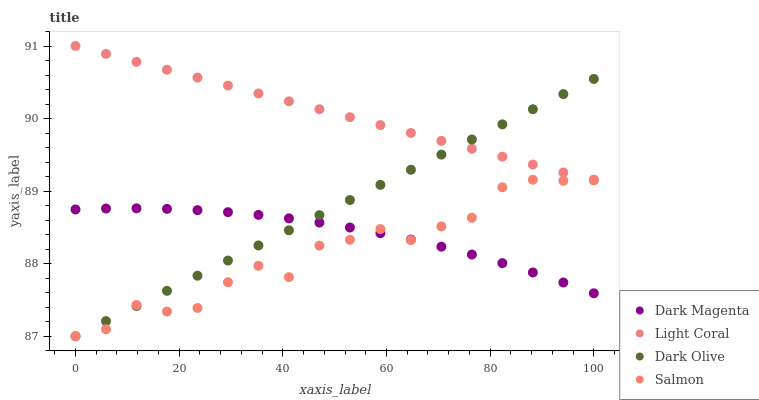Does Salmon have the minimum area under the curve?
Answer yes or no. Yes. Does Light Coral have the maximum area under the curve?
Answer yes or no. Yes. Does Dark Olive have the minimum area under the curve?
Answer yes or no. No. Does Dark Olive have the maximum area under the curve?
Answer yes or no. No. Is Light Coral the smoothest?
Answer yes or no. Yes. Is Salmon the roughest?
Answer yes or no. Yes. Is Dark Olive the smoothest?
Answer yes or no. No. Is Dark Olive the roughest?
Answer yes or no. No. Does Dark Olive have the lowest value?
Answer yes or no. Yes. Does Dark Magenta have the lowest value?
Answer yes or no. No. Does Light Coral have the highest value?
Answer yes or no. Yes. Does Dark Olive have the highest value?
Answer yes or no. No. Is Dark Magenta less than Light Coral?
Answer yes or no. Yes. Is Light Coral greater than Dark Magenta?
Answer yes or no. Yes. Does Salmon intersect Dark Olive?
Answer yes or no. Yes. Is Salmon less than Dark Olive?
Answer yes or no. No. Is Salmon greater than Dark Olive?
Answer yes or no. No. Does Dark Magenta intersect Light Coral?
Answer yes or no. No. 